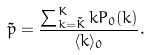Convert formula to latex. <formula><loc_0><loc_0><loc_500><loc_500>\tilde { p } = \frac { \sum _ { k = \tilde { K } } ^ { K } k P _ { 0 } ( k ) } { \langle k \rangle _ { 0 } } .</formula> 